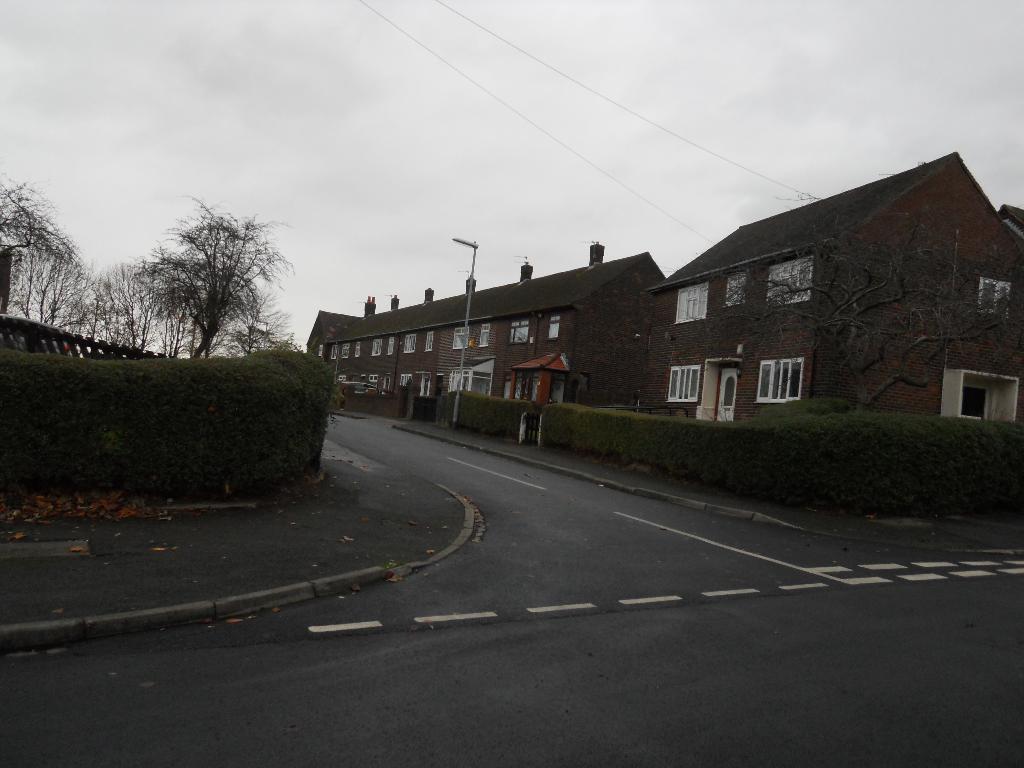Could you give a brief overview of what you see in this image? This picture is clicked outside. In the foreground we can see the road and a sidewalk and we can see the shrubs and houses and we can see the windows of the houses. In the background we can see the sky, cables, trees and a light attached to the pole. 